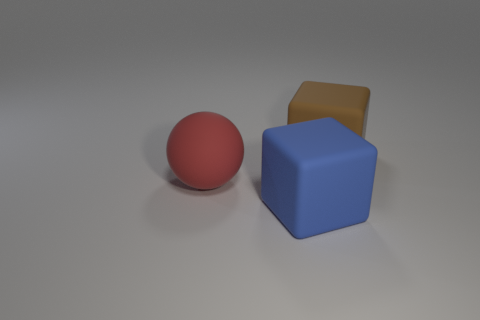There is a matte object left of the big cube in front of the ball; what size is it?
Give a very brief answer. Large. There is a thing to the right of the large matte cube in front of the large cube behind the big red rubber thing; what is its shape?
Your answer should be compact. Cube. There is another block that is made of the same material as the brown cube; what is its color?
Your response must be concise. Blue. The cube in front of the brown matte thing that is right of the object that is in front of the ball is what color?
Your answer should be compact. Blue. How many balls are either large rubber objects or brown objects?
Make the answer very short. 1. Does the rubber ball have the same color as the matte block in front of the large rubber sphere?
Your answer should be very brief. No. The ball has what color?
Offer a terse response. Red. How many things are brown matte blocks or red objects?
Keep it short and to the point. 2. There is another block that is the same size as the brown matte cube; what is its material?
Keep it short and to the point. Rubber. How big is the block in front of the large brown thing?
Provide a succinct answer. Large. 